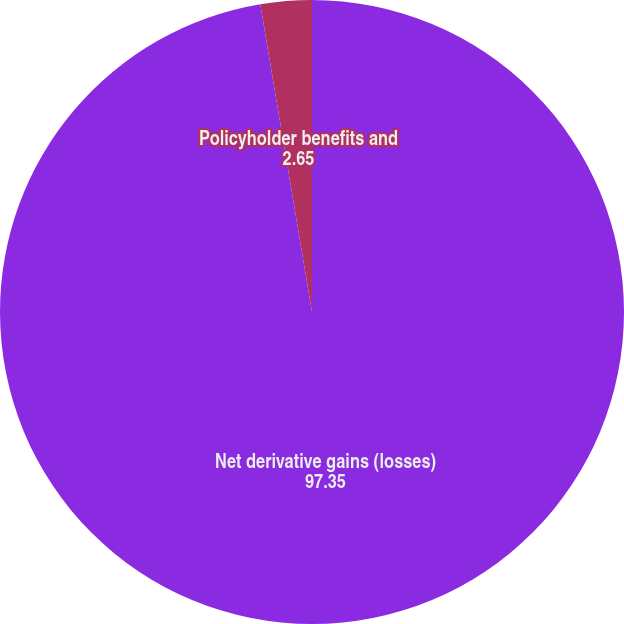<chart> <loc_0><loc_0><loc_500><loc_500><pie_chart><fcel>Net derivative gains (losses)<fcel>Policyholder benefits and<nl><fcel>97.35%<fcel>2.65%<nl></chart> 